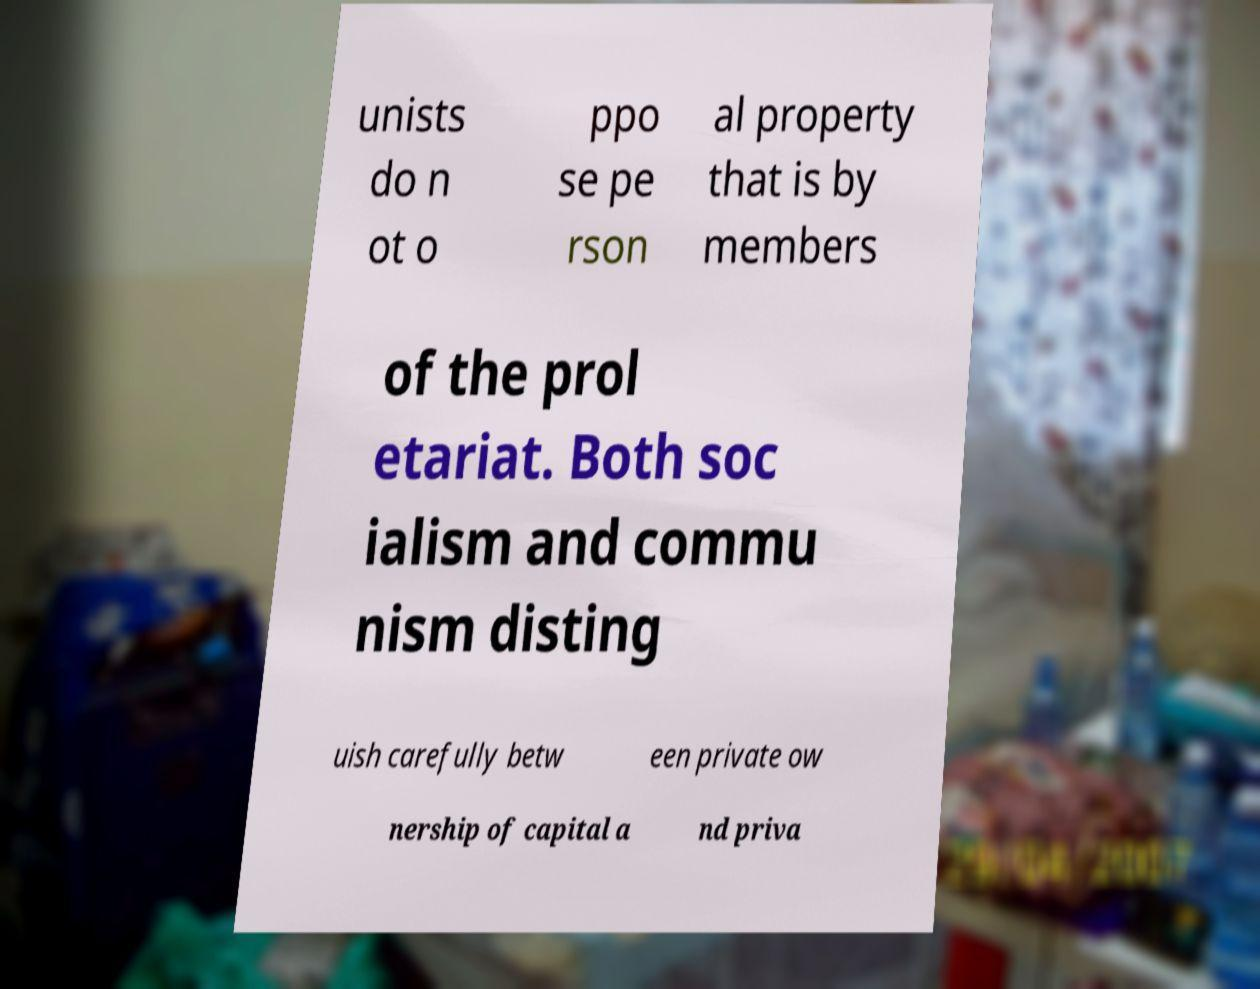Can you read and provide the text displayed in the image?This photo seems to have some interesting text. Can you extract and type it out for me? unists do n ot o ppo se pe rson al property that is by members of the prol etariat. Both soc ialism and commu nism disting uish carefully betw een private ow nership of capital a nd priva 